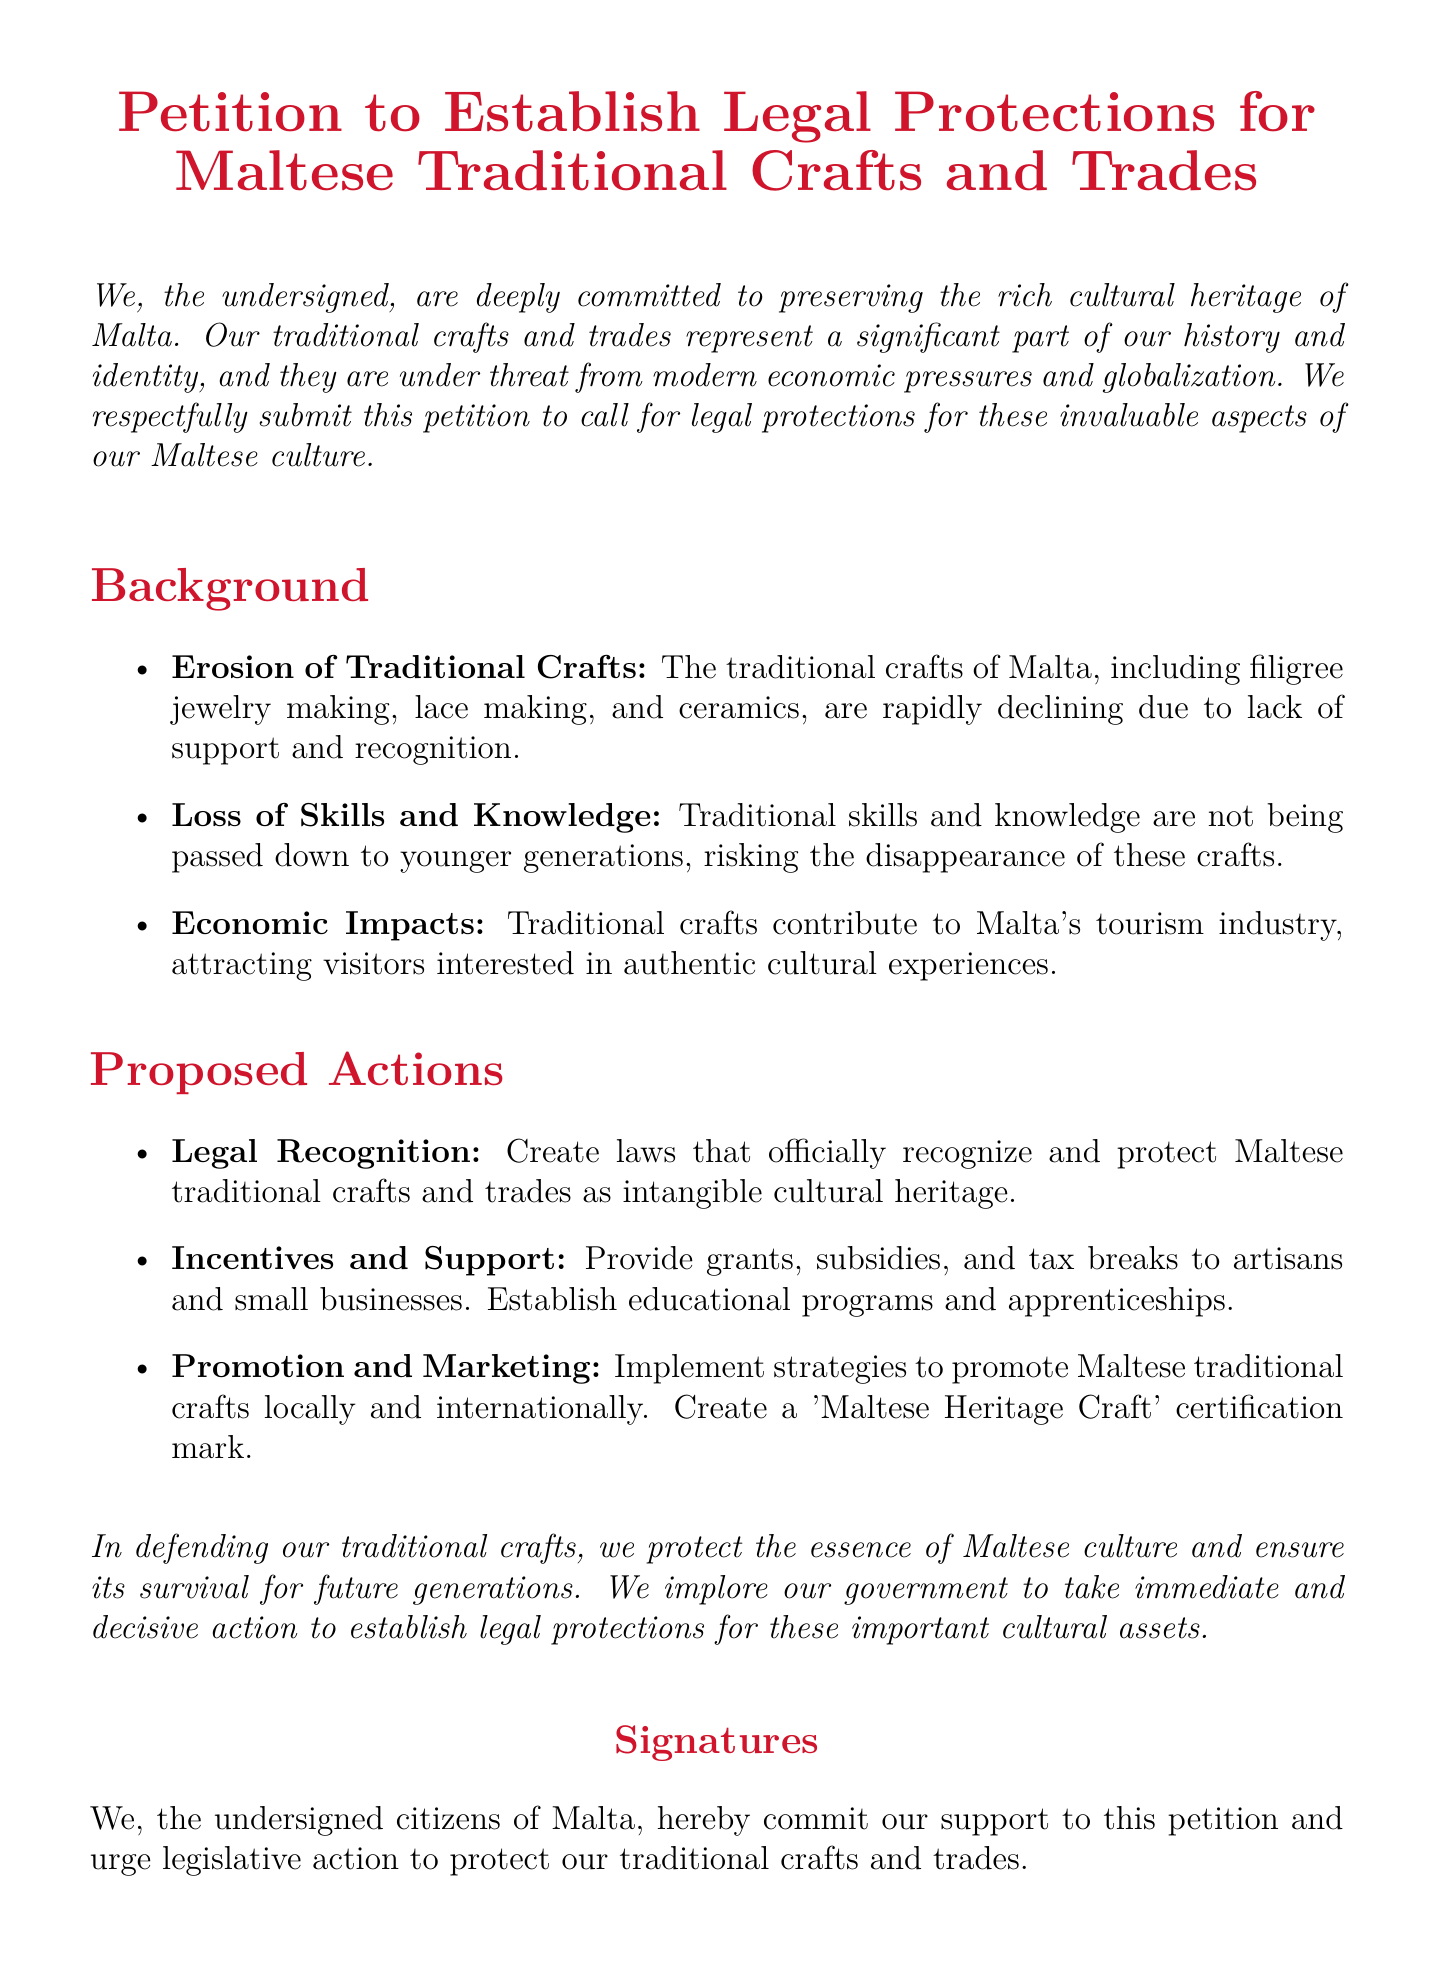What is the main purpose of the petition? The purpose of the petition is to call for legal protections for Maltese traditional crafts and trades.
Answer: Legal protections for Maltese traditional crafts and trades What does the petition highlight as a threat to traditional crafts? The petition states that traditional crafts are under threat from modern economic pressures and globalization.
Answer: Modern economic pressures and globalization Name one traditional craft mentioned in the document. The document refers to filigree jewelry making as one of the traditional crafts.
Answer: Filigree jewelry making What is proposed to support artisans and small businesses? Providing grants, subsidies, and tax breaks is suggested as support for artisans and small businesses.
Answer: Grants, subsidies, and tax breaks How many action proposals are listed in the document? The document lists a total of three proposed actions for protecting traditional crafts.
Answer: Three What is suggested to promote Maltese traditional crafts locally and internationally? Implementing strategies to promote Maltese traditional crafts is suggested.
Answer: Strategies to promote Maltese traditional crafts What type of certification mark is proposed in the document? The document proposes the creation of a 'Maltese Heritage Craft' certification mark.
Answer: 'Maltese Heritage Craft' certification mark What does the petition urge the government to do? The petition implores the government to take immediate and decisive action regarding traditional crafts.
Answer: Take immediate and decisive action Which cultural aspect do traditional crafts contribute to in Malta? Traditional crafts contribute significantly to Malta's tourism industry.
Answer: Tourism industry 